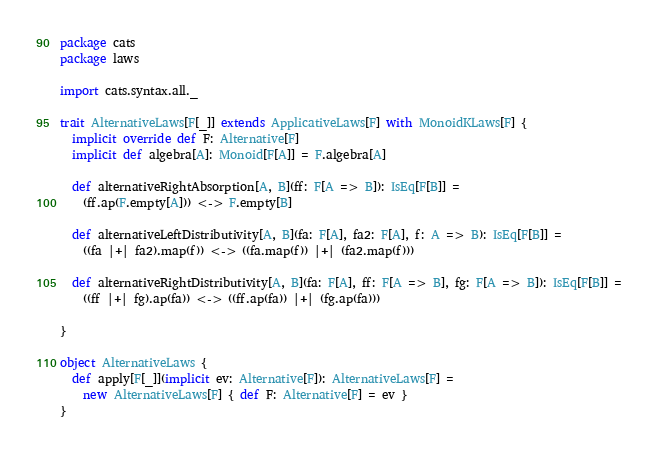<code> <loc_0><loc_0><loc_500><loc_500><_Scala_>package cats
package laws

import cats.syntax.all._

trait AlternativeLaws[F[_]] extends ApplicativeLaws[F] with MonoidKLaws[F] {
  implicit override def F: Alternative[F]
  implicit def algebra[A]: Monoid[F[A]] = F.algebra[A]

  def alternativeRightAbsorption[A, B](ff: F[A => B]): IsEq[F[B]] =
    (ff.ap(F.empty[A])) <-> F.empty[B]

  def alternativeLeftDistributivity[A, B](fa: F[A], fa2: F[A], f: A => B): IsEq[F[B]] =
    ((fa |+| fa2).map(f)) <-> ((fa.map(f)) |+| (fa2.map(f)))

  def alternativeRightDistributivity[A, B](fa: F[A], ff: F[A => B], fg: F[A => B]): IsEq[F[B]] =
    ((ff |+| fg).ap(fa)) <-> ((ff.ap(fa)) |+| (fg.ap(fa)))

}

object AlternativeLaws {
  def apply[F[_]](implicit ev: Alternative[F]): AlternativeLaws[F] =
    new AlternativeLaws[F] { def F: Alternative[F] = ev }
}
</code> 